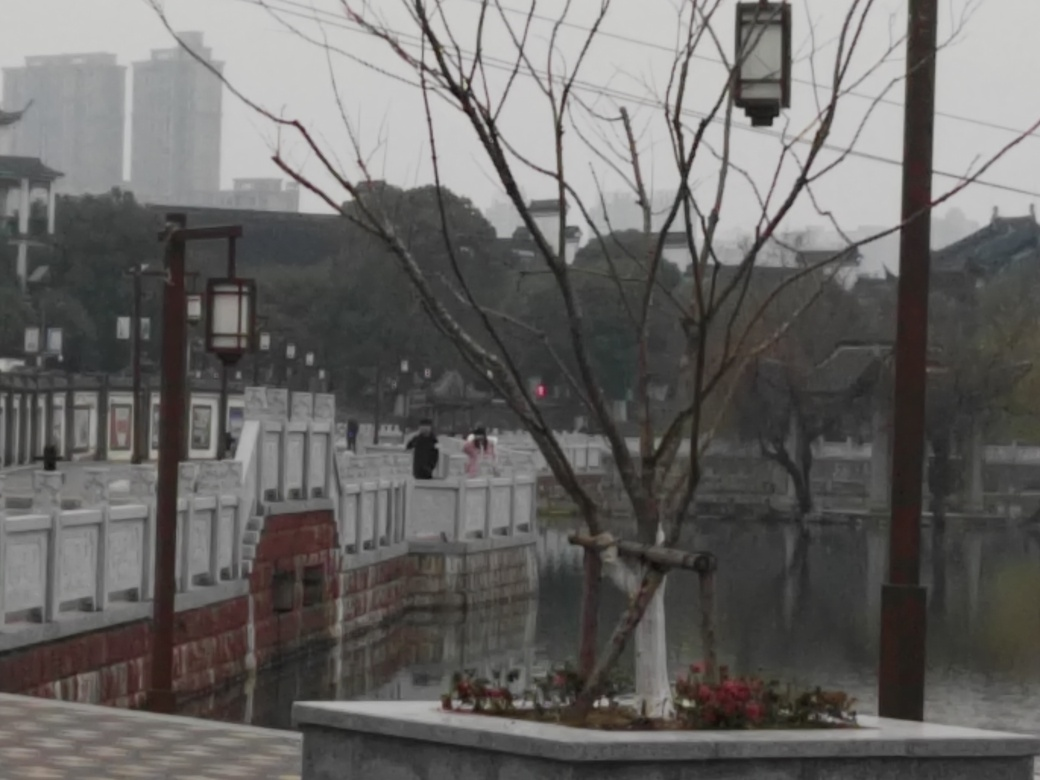Is the lighting sufficient in the image?
A. Yes
B. No
Answer with the option's letter from the given choices directly.
 A. 